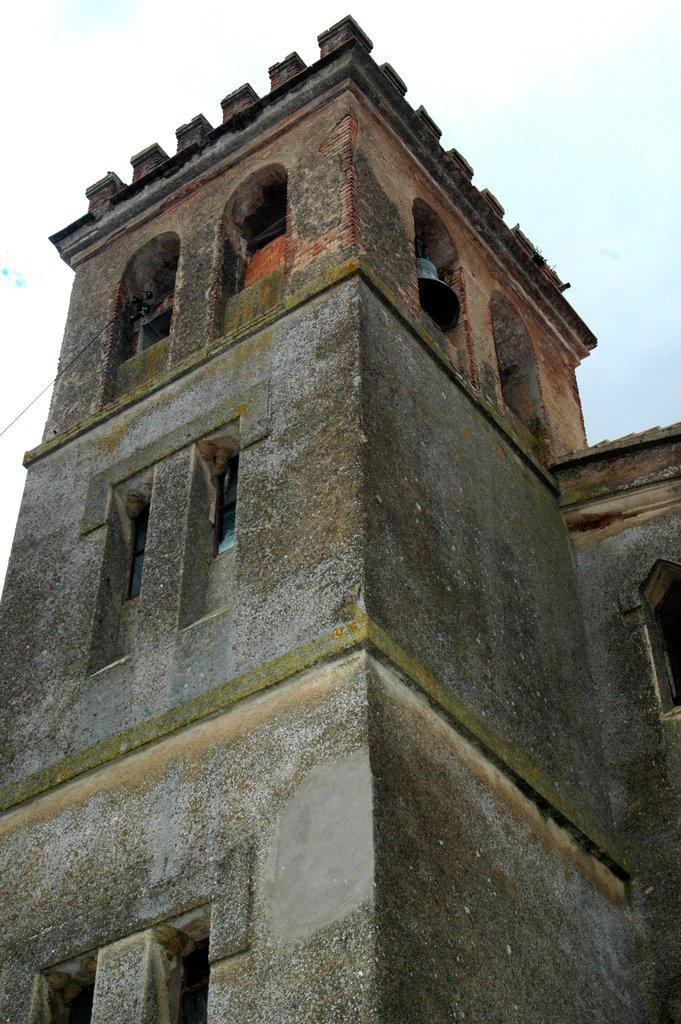What is the main subject of the image? The main subject of the image is a building. What specific features can be observed on the building? The building has windows. What can be seen in the background of the image? The sky is visible in the background of the image. How many donkeys can be seen grazing on the coast in the image? There are no donkeys or coast visible in the image; it features a building with windows and a sky background. What is the price of the building in the image? The price of the building is not mentioned in the image, as it is a photograph and not a real estate listing. 